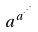Convert formula to latex. <formula><loc_0><loc_0><loc_500><loc_500>a ^ { a ^ { \cdot ^ { \cdot ^ { \cdot } } } }</formula> 